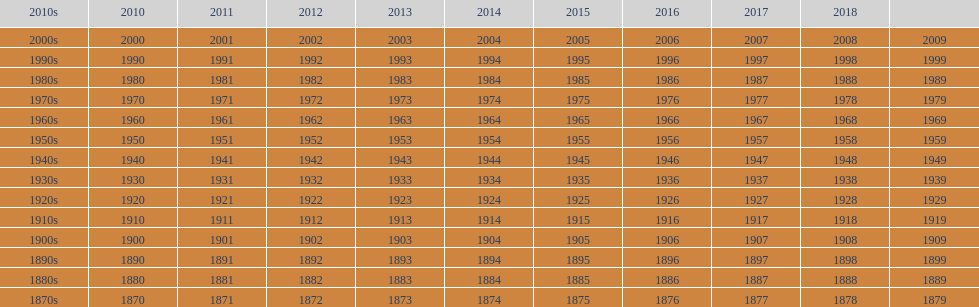True/false: all years go in consecutive order? True. 